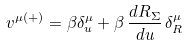<formula> <loc_0><loc_0><loc_500><loc_500>v ^ { \mu ( + ) } = \beta \delta ^ { \mu } _ { u } + \beta \, \frac { d R _ { \Sigma } } { d u } \, \delta ^ { \mu } _ { R }</formula> 